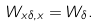Convert formula to latex. <formula><loc_0><loc_0><loc_500><loc_500>W _ { x \delta , x } = W _ { \delta } .</formula> 